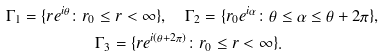<formula> <loc_0><loc_0><loc_500><loc_500>\Gamma _ { 1 } = \{ r e ^ { i \theta } \colon r _ { 0 } & \leq r < \infty \} , \quad \Gamma _ { 2 } = \{ r _ { 0 } e ^ { i \alpha } \colon \theta \leq \alpha \leq \theta + 2 \pi \} , \\ & \Gamma _ { 3 } = \{ r e ^ { i ( \theta + 2 \pi ) } \colon r _ { 0 } \leq r < \infty \} .</formula> 